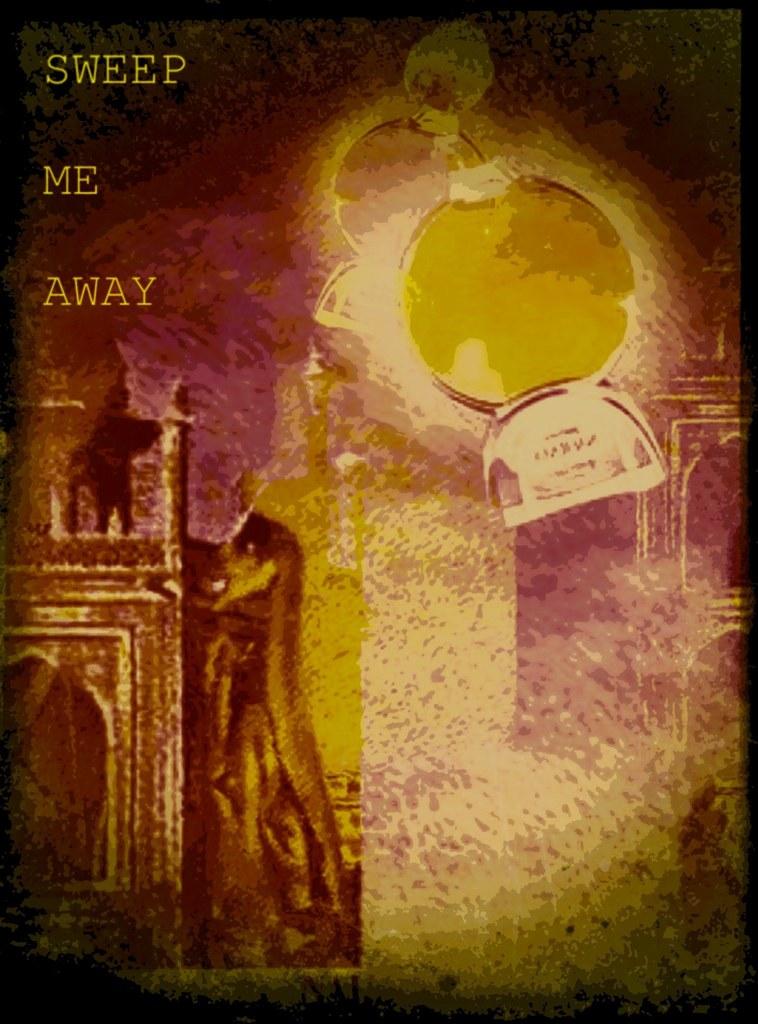Is sweep me away a book?
Your answer should be compact. Yes. This some story book?
Give a very brief answer. Yes. 